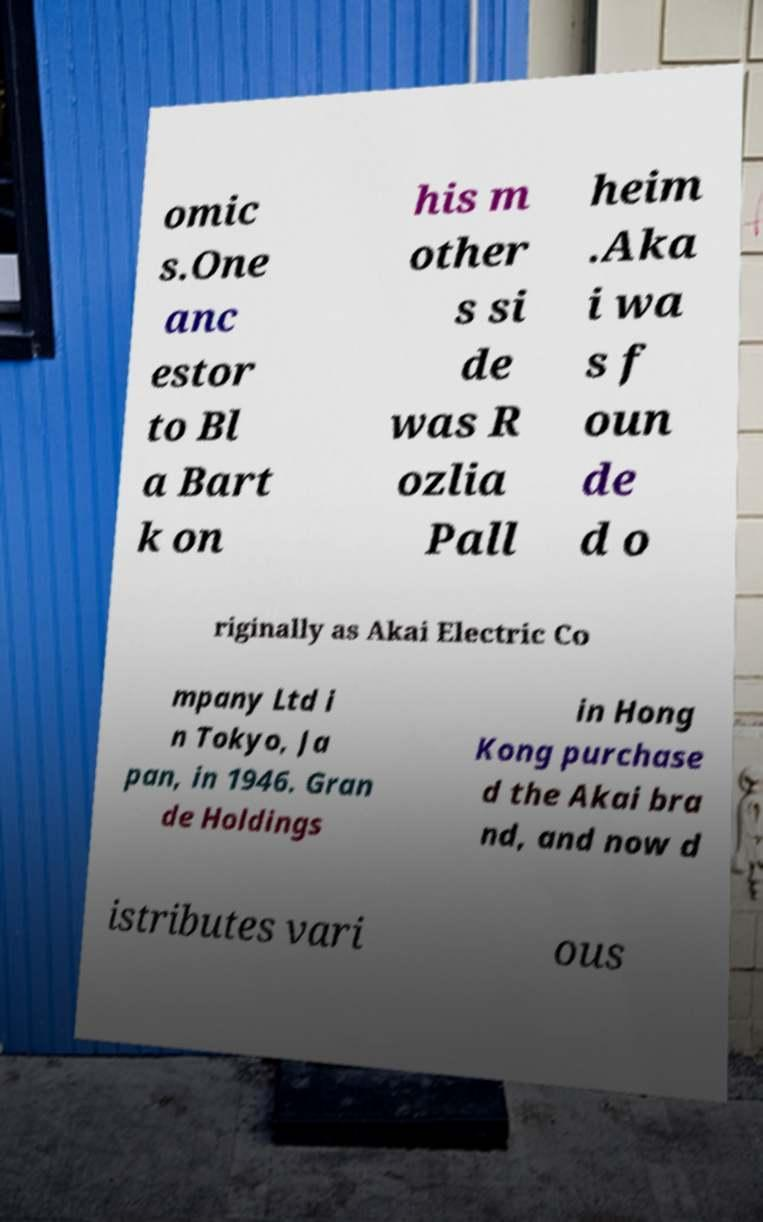Could you extract and type out the text from this image? omic s.One anc estor to Bl a Bart k on his m other s si de was R ozlia Pall heim .Aka i wa s f oun de d o riginally as Akai Electric Co mpany Ltd i n Tokyo, Ja pan, in 1946. Gran de Holdings in Hong Kong purchase d the Akai bra nd, and now d istributes vari ous 